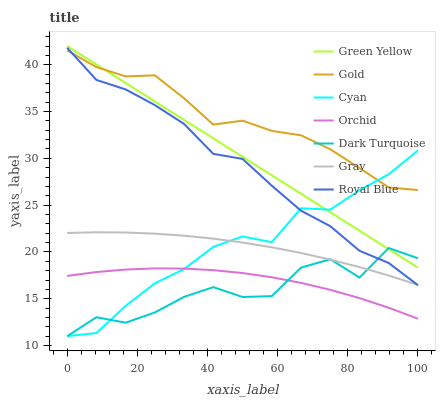Does Dark Turquoise have the minimum area under the curve?
Answer yes or no. Yes. Does Gold have the maximum area under the curve?
Answer yes or no. Yes. Does Gold have the minimum area under the curve?
Answer yes or no. No. Does Dark Turquoise have the maximum area under the curve?
Answer yes or no. No. Is Green Yellow the smoothest?
Answer yes or no. Yes. Is Dark Turquoise the roughest?
Answer yes or no. Yes. Is Gold the smoothest?
Answer yes or no. No. Is Gold the roughest?
Answer yes or no. No. Does Dark Turquoise have the lowest value?
Answer yes or no. Yes. Does Gold have the lowest value?
Answer yes or no. No. Does Green Yellow have the highest value?
Answer yes or no. Yes. Does Gold have the highest value?
Answer yes or no. No. Is Orchid less than Green Yellow?
Answer yes or no. Yes. Is Green Yellow greater than Royal Blue?
Answer yes or no. Yes. Does Dark Turquoise intersect Gray?
Answer yes or no. Yes. Is Dark Turquoise less than Gray?
Answer yes or no. No. Is Dark Turquoise greater than Gray?
Answer yes or no. No. Does Orchid intersect Green Yellow?
Answer yes or no. No. 